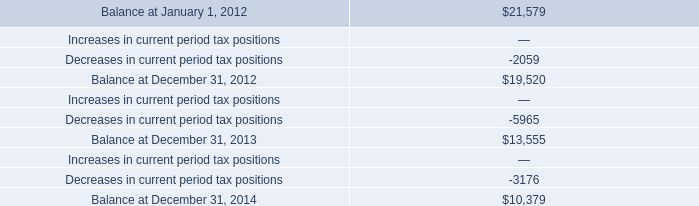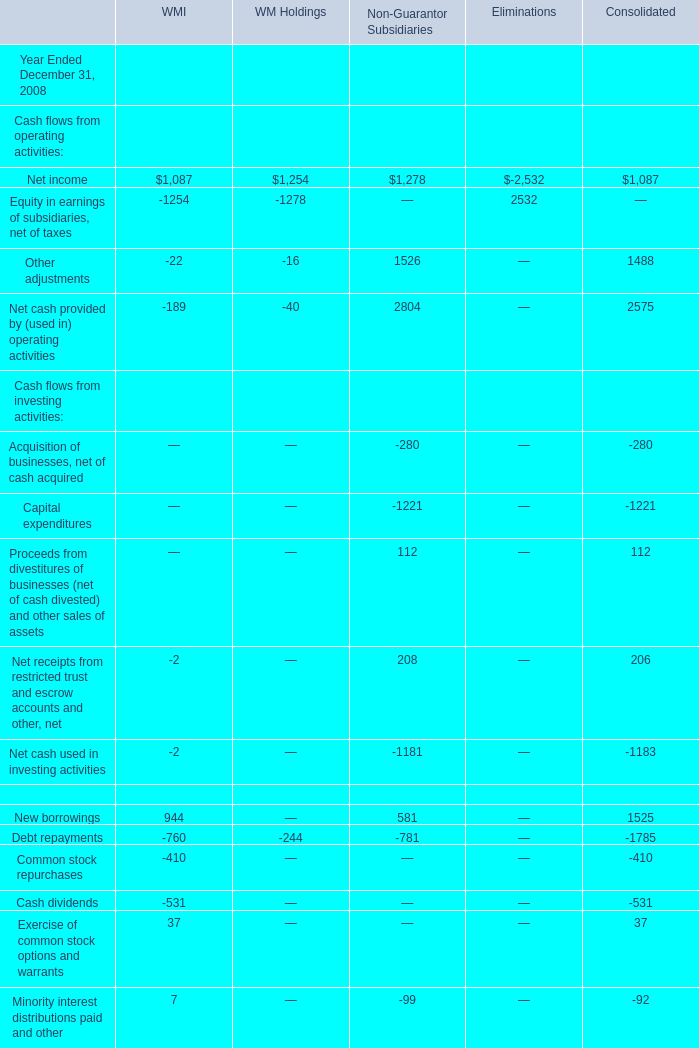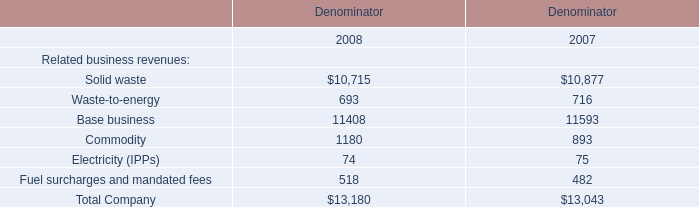what percentage of the company 2019s valuation allowance consisted of a discrete tax benefit in 2013? 
Computations: (2979 / 13555)
Answer: 0.21977. 